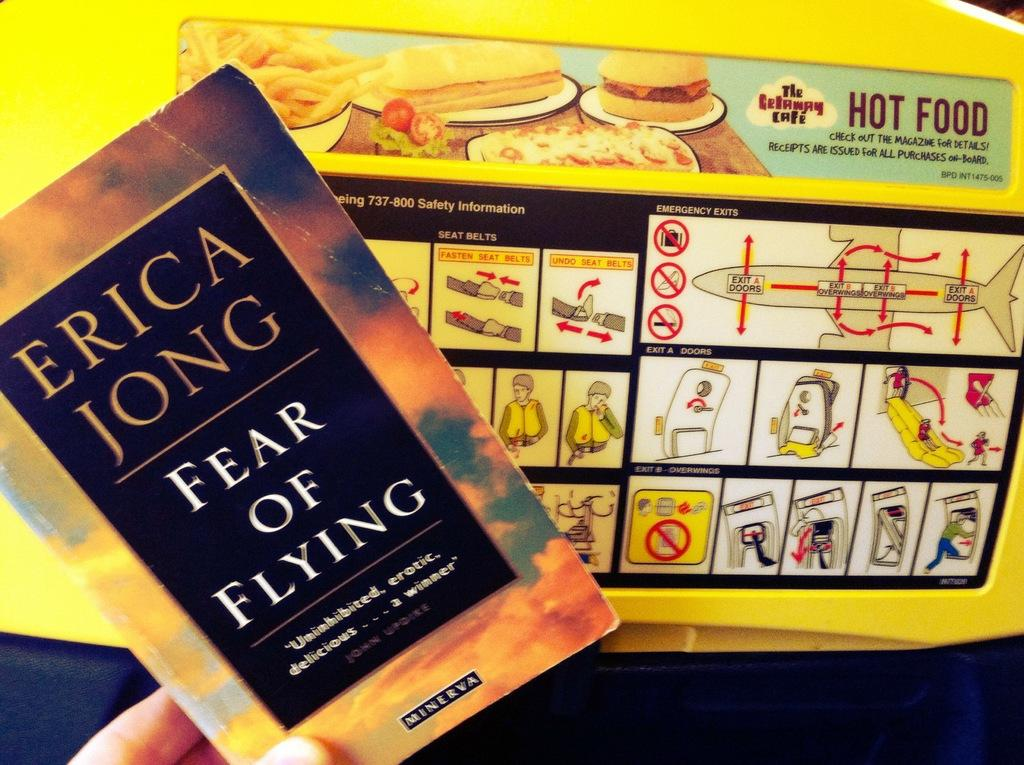Provide a one-sentence caption for the provided image. Person holding a book by Erica Jong named Fear of Flying. 